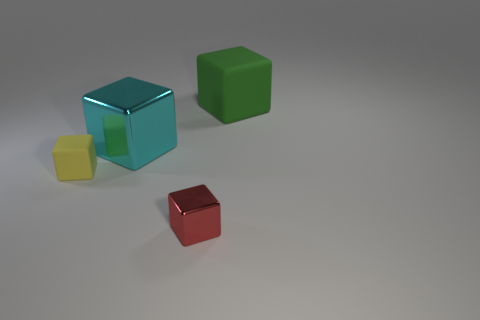Can you describe the colors and shapes present in the image, and how they relate to each other? The image showcases four objects, each with distinct colors and identical shapes. There are three cubes, one cyan, one green, and one red, and a smaller, yellow cube. The cubes are spatially separated, suggesting no direct interaction between them, but their uniform shape creates a sense of cohesiveness in the scene. 